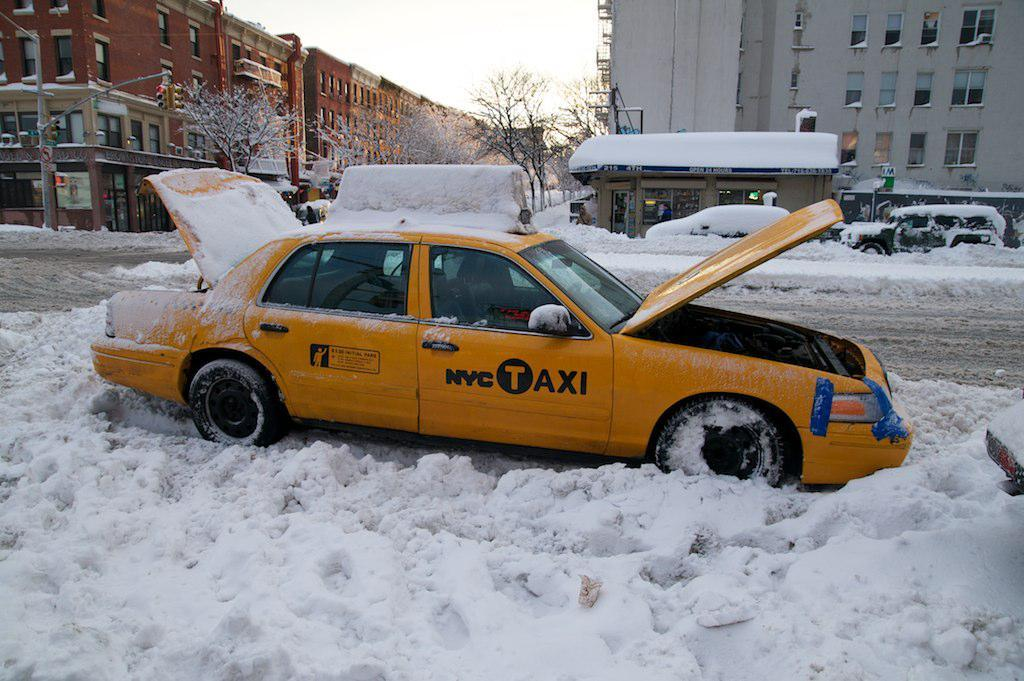What is the main subject of the image? The main subject of the image is a car parked on the snow. Can you describe the surrounding environment in the image? There are other vehicles parked on the road in the background, as well as buildings, trees, and the sky visible in the background. How many vehicles can be seen in the image? There is at least one car parked on the snow, and other vehicles parked on the road in the background. What type of wool is being used by the secretary in the image? There is no secretary or wool present in the image; it features a car parked on the snow and other vehicles, buildings, trees, and the sky in the background. 